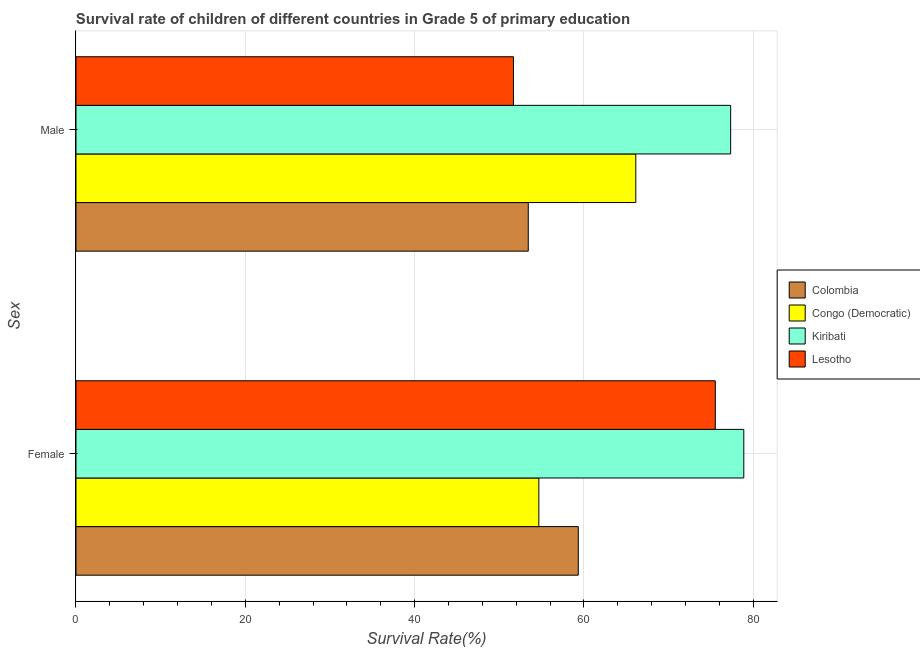How many bars are there on the 1st tick from the top?
Keep it short and to the point. 4. What is the survival rate of female students in primary education in Congo (Democratic)?
Ensure brevity in your answer.  54.68. Across all countries, what is the maximum survival rate of male students in primary education?
Give a very brief answer. 77.34. Across all countries, what is the minimum survival rate of female students in primary education?
Provide a succinct answer. 54.68. In which country was the survival rate of female students in primary education maximum?
Your answer should be compact. Kiribati. In which country was the survival rate of male students in primary education minimum?
Give a very brief answer. Lesotho. What is the total survival rate of female students in primary education in the graph?
Keep it short and to the point. 268.44. What is the difference between the survival rate of female students in primary education in Colombia and that in Kiribati?
Provide a succinct answer. -19.55. What is the difference between the survival rate of male students in primary education in Colombia and the survival rate of female students in primary education in Kiribati?
Your answer should be very brief. -25.46. What is the average survival rate of male students in primary education per country?
Provide a short and direct response. 62.15. What is the difference between the survival rate of female students in primary education and survival rate of male students in primary education in Colombia?
Your response must be concise. 5.91. What is the ratio of the survival rate of female students in primary education in Lesotho to that in Colombia?
Offer a very short reply. 1.27. Is the survival rate of male students in primary education in Congo (Democratic) less than that in Colombia?
Offer a terse response. No. In how many countries, is the survival rate of male students in primary education greater than the average survival rate of male students in primary education taken over all countries?
Your answer should be compact. 2. What does the 4th bar from the bottom in Male represents?
Make the answer very short. Lesotho. Are all the bars in the graph horizontal?
Give a very brief answer. Yes. Are the values on the major ticks of X-axis written in scientific E-notation?
Your answer should be compact. No. Does the graph contain any zero values?
Make the answer very short. No. Where does the legend appear in the graph?
Offer a very short reply. Center right. How are the legend labels stacked?
Your answer should be compact. Vertical. What is the title of the graph?
Offer a very short reply. Survival rate of children of different countries in Grade 5 of primary education. Does "European Union" appear as one of the legend labels in the graph?
Make the answer very short. No. What is the label or title of the X-axis?
Keep it short and to the point. Survival Rate(%). What is the label or title of the Y-axis?
Your answer should be very brief. Sex. What is the Survival Rate(%) in Colombia in Female?
Offer a terse response. 59.34. What is the Survival Rate(%) in Congo (Democratic) in Female?
Provide a succinct answer. 54.68. What is the Survival Rate(%) in Kiribati in Female?
Ensure brevity in your answer.  78.89. What is the Survival Rate(%) of Lesotho in Female?
Make the answer very short. 75.52. What is the Survival Rate(%) of Colombia in Male?
Give a very brief answer. 53.43. What is the Survival Rate(%) in Congo (Democratic) in Male?
Offer a terse response. 66.14. What is the Survival Rate(%) of Kiribati in Male?
Provide a succinct answer. 77.34. What is the Survival Rate(%) of Lesotho in Male?
Your answer should be very brief. 51.68. Across all Sex, what is the maximum Survival Rate(%) of Colombia?
Your answer should be very brief. 59.34. Across all Sex, what is the maximum Survival Rate(%) of Congo (Democratic)?
Provide a succinct answer. 66.14. Across all Sex, what is the maximum Survival Rate(%) in Kiribati?
Your answer should be very brief. 78.89. Across all Sex, what is the maximum Survival Rate(%) of Lesotho?
Keep it short and to the point. 75.52. Across all Sex, what is the minimum Survival Rate(%) of Colombia?
Your answer should be very brief. 53.43. Across all Sex, what is the minimum Survival Rate(%) of Congo (Democratic)?
Your response must be concise. 54.68. Across all Sex, what is the minimum Survival Rate(%) in Kiribati?
Your answer should be very brief. 77.34. Across all Sex, what is the minimum Survival Rate(%) in Lesotho?
Ensure brevity in your answer.  51.68. What is the total Survival Rate(%) in Colombia in the graph?
Make the answer very short. 112.77. What is the total Survival Rate(%) in Congo (Democratic) in the graph?
Offer a very short reply. 120.82. What is the total Survival Rate(%) in Kiribati in the graph?
Provide a succinct answer. 156.23. What is the total Survival Rate(%) in Lesotho in the graph?
Provide a short and direct response. 127.21. What is the difference between the Survival Rate(%) of Colombia in Female and that in Male?
Give a very brief answer. 5.91. What is the difference between the Survival Rate(%) in Congo (Democratic) in Female and that in Male?
Offer a terse response. -11.46. What is the difference between the Survival Rate(%) in Kiribati in Female and that in Male?
Your answer should be very brief. 1.55. What is the difference between the Survival Rate(%) of Lesotho in Female and that in Male?
Your answer should be compact. 23.84. What is the difference between the Survival Rate(%) of Colombia in Female and the Survival Rate(%) of Congo (Democratic) in Male?
Offer a terse response. -6.8. What is the difference between the Survival Rate(%) of Colombia in Female and the Survival Rate(%) of Kiribati in Male?
Provide a short and direct response. -18. What is the difference between the Survival Rate(%) in Colombia in Female and the Survival Rate(%) in Lesotho in Male?
Your answer should be very brief. 7.66. What is the difference between the Survival Rate(%) of Congo (Democratic) in Female and the Survival Rate(%) of Kiribati in Male?
Provide a succinct answer. -22.66. What is the difference between the Survival Rate(%) in Congo (Democratic) in Female and the Survival Rate(%) in Lesotho in Male?
Ensure brevity in your answer.  3. What is the difference between the Survival Rate(%) of Kiribati in Female and the Survival Rate(%) of Lesotho in Male?
Offer a very short reply. 27.21. What is the average Survival Rate(%) of Colombia per Sex?
Ensure brevity in your answer.  56.38. What is the average Survival Rate(%) in Congo (Democratic) per Sex?
Keep it short and to the point. 60.41. What is the average Survival Rate(%) of Kiribati per Sex?
Ensure brevity in your answer.  78.12. What is the average Survival Rate(%) of Lesotho per Sex?
Make the answer very short. 63.6. What is the difference between the Survival Rate(%) in Colombia and Survival Rate(%) in Congo (Democratic) in Female?
Keep it short and to the point. 4.66. What is the difference between the Survival Rate(%) in Colombia and Survival Rate(%) in Kiribati in Female?
Offer a very short reply. -19.55. What is the difference between the Survival Rate(%) of Colombia and Survival Rate(%) of Lesotho in Female?
Provide a short and direct response. -16.19. What is the difference between the Survival Rate(%) in Congo (Democratic) and Survival Rate(%) in Kiribati in Female?
Your answer should be very brief. -24.21. What is the difference between the Survival Rate(%) of Congo (Democratic) and Survival Rate(%) of Lesotho in Female?
Your answer should be compact. -20.85. What is the difference between the Survival Rate(%) in Kiribati and Survival Rate(%) in Lesotho in Female?
Keep it short and to the point. 3.37. What is the difference between the Survival Rate(%) in Colombia and Survival Rate(%) in Congo (Democratic) in Male?
Offer a terse response. -12.71. What is the difference between the Survival Rate(%) of Colombia and Survival Rate(%) of Kiribati in Male?
Provide a short and direct response. -23.91. What is the difference between the Survival Rate(%) of Colombia and Survival Rate(%) of Lesotho in Male?
Your response must be concise. 1.75. What is the difference between the Survival Rate(%) of Congo (Democratic) and Survival Rate(%) of Kiribati in Male?
Offer a very short reply. -11.2. What is the difference between the Survival Rate(%) in Congo (Democratic) and Survival Rate(%) in Lesotho in Male?
Offer a very short reply. 14.45. What is the difference between the Survival Rate(%) of Kiribati and Survival Rate(%) of Lesotho in Male?
Offer a terse response. 25.66. What is the ratio of the Survival Rate(%) in Colombia in Female to that in Male?
Provide a short and direct response. 1.11. What is the ratio of the Survival Rate(%) of Congo (Democratic) in Female to that in Male?
Your response must be concise. 0.83. What is the ratio of the Survival Rate(%) of Kiribati in Female to that in Male?
Offer a very short reply. 1.02. What is the ratio of the Survival Rate(%) of Lesotho in Female to that in Male?
Your response must be concise. 1.46. What is the difference between the highest and the second highest Survival Rate(%) of Colombia?
Make the answer very short. 5.91. What is the difference between the highest and the second highest Survival Rate(%) of Congo (Democratic)?
Provide a short and direct response. 11.46. What is the difference between the highest and the second highest Survival Rate(%) in Kiribati?
Offer a terse response. 1.55. What is the difference between the highest and the second highest Survival Rate(%) in Lesotho?
Offer a very short reply. 23.84. What is the difference between the highest and the lowest Survival Rate(%) in Colombia?
Your answer should be very brief. 5.91. What is the difference between the highest and the lowest Survival Rate(%) in Congo (Democratic)?
Your response must be concise. 11.46. What is the difference between the highest and the lowest Survival Rate(%) of Kiribati?
Your answer should be compact. 1.55. What is the difference between the highest and the lowest Survival Rate(%) of Lesotho?
Your answer should be compact. 23.84. 